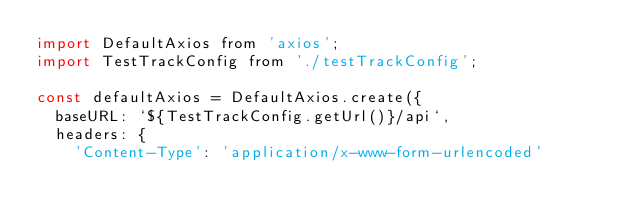<code> <loc_0><loc_0><loc_500><loc_500><_JavaScript_>import DefaultAxios from 'axios';
import TestTrackConfig from './testTrackConfig';

const defaultAxios = DefaultAxios.create({
  baseURL: `${TestTrackConfig.getUrl()}/api`,
  headers: {
    'Content-Type': 'application/x-www-form-urlencoded'</code> 